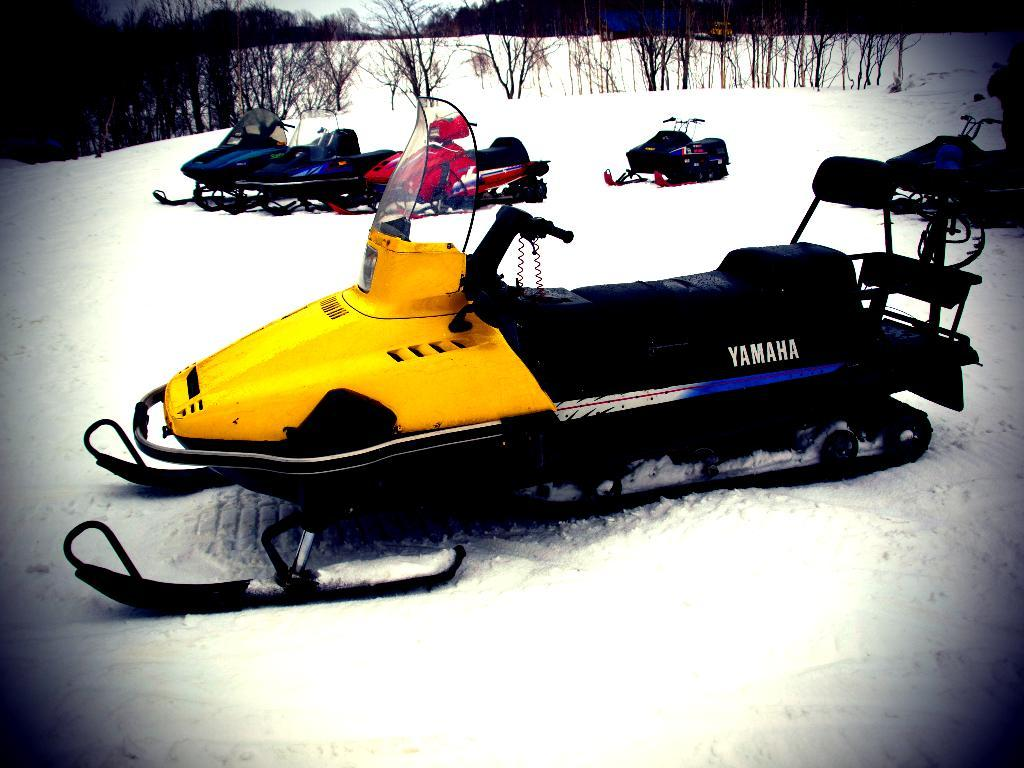What type of vehicles are in the image? There are snowmobiles in the image. Where are the snowmobiles located? The snowmobiles are on the snow. What colors can be seen on the snowmobiles? The snowmobiles are in red, yellow, black, and blue colors. What can be seen in the background of the image? There are trees and the sky visible in the background of the image. What type of end can be seen on the snowmobiles in the image? There is no specific end mentioned in the image; the snowmobiles are simply depicted as vehicles on the snow. 